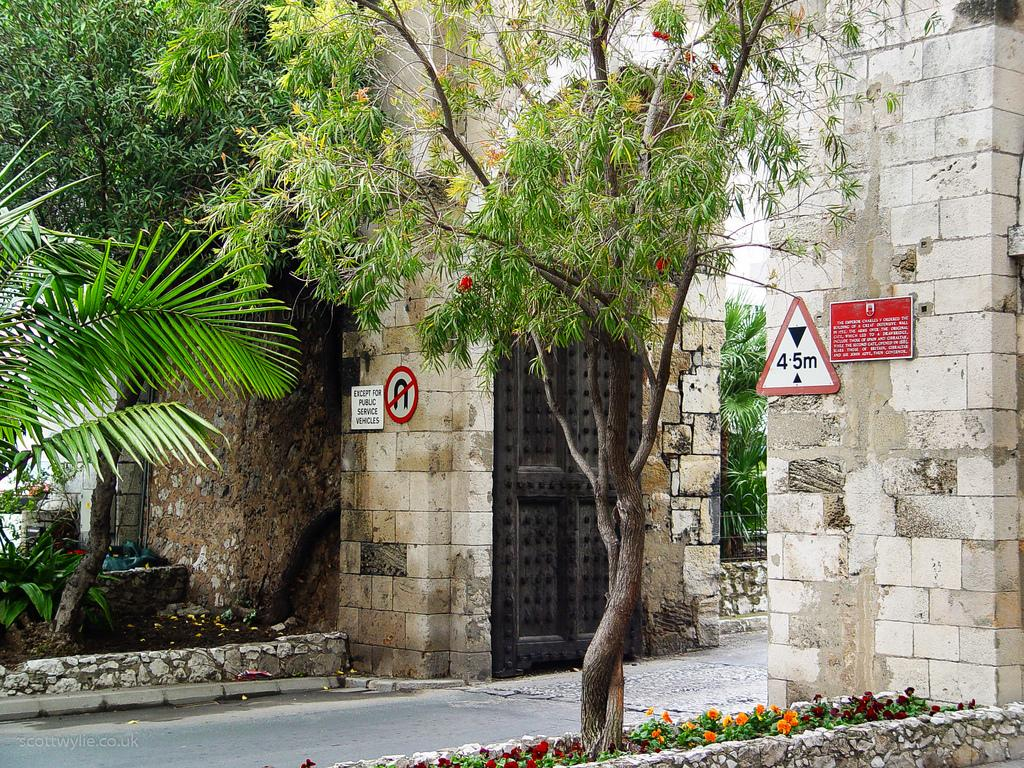What type of vegetation can be seen in the image? There are trees, plants, and flowers in the image. What is on the wall in the image? There are boards on the wall, and there is text on the board. What type of surface is visible in the image? There is a road in the image. Can you tell me where the nest of the bird is located in the image? There is no nest of a bird present in the image. What knowledge can be gained from the text on the board in the image? The text on the board cannot be read or interpreted in the image, so it is not possible to determine what knowledge can be gained from it. 